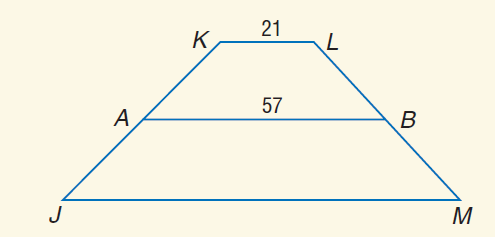Answer the mathemtical geometry problem and directly provide the correct option letter.
Question: For trapezoid J K L M, A and B are midpoints of the legs. If A B = 57 and K L = 21, find J M.
Choices: A: 21 B: 57 C: 87 D: 93 D 